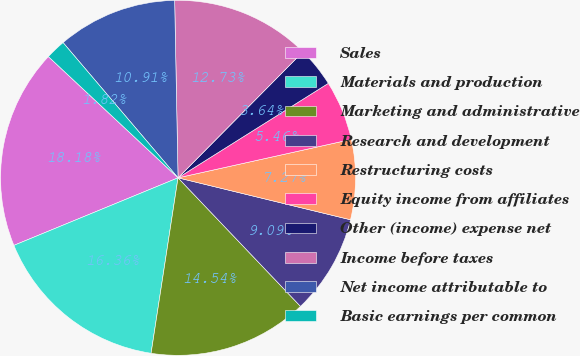Convert chart to OTSL. <chart><loc_0><loc_0><loc_500><loc_500><pie_chart><fcel>Sales<fcel>Materials and production<fcel>Marketing and administrative<fcel>Research and development<fcel>Restructuring costs<fcel>Equity income from affiliates<fcel>Other (income) expense net<fcel>Income before taxes<fcel>Net income attributable to<fcel>Basic earnings per common<nl><fcel>18.18%<fcel>16.36%<fcel>14.54%<fcel>9.09%<fcel>7.27%<fcel>5.46%<fcel>3.64%<fcel>12.73%<fcel>10.91%<fcel>1.82%<nl></chart> 